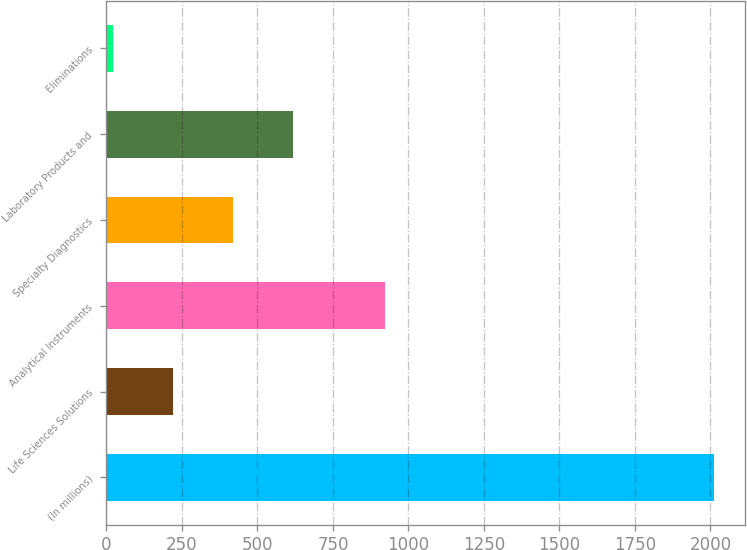Convert chart. <chart><loc_0><loc_0><loc_500><loc_500><bar_chart><fcel>(In millions)<fcel>Life Sciences Solutions<fcel>Analytical Instruments<fcel>Specialty Diagnostics<fcel>Laboratory Products and<fcel>Eliminations<nl><fcel>2013<fcel>220.29<fcel>921.5<fcel>419.48<fcel>618.67<fcel>21.1<nl></chart> 